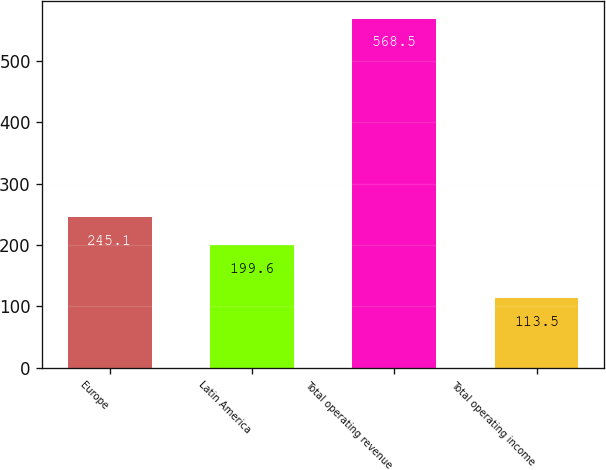Convert chart to OTSL. <chart><loc_0><loc_0><loc_500><loc_500><bar_chart><fcel>Europe<fcel>Latin America<fcel>Total operating revenue<fcel>Total operating income<nl><fcel>245.1<fcel>199.6<fcel>568.5<fcel>113.5<nl></chart> 